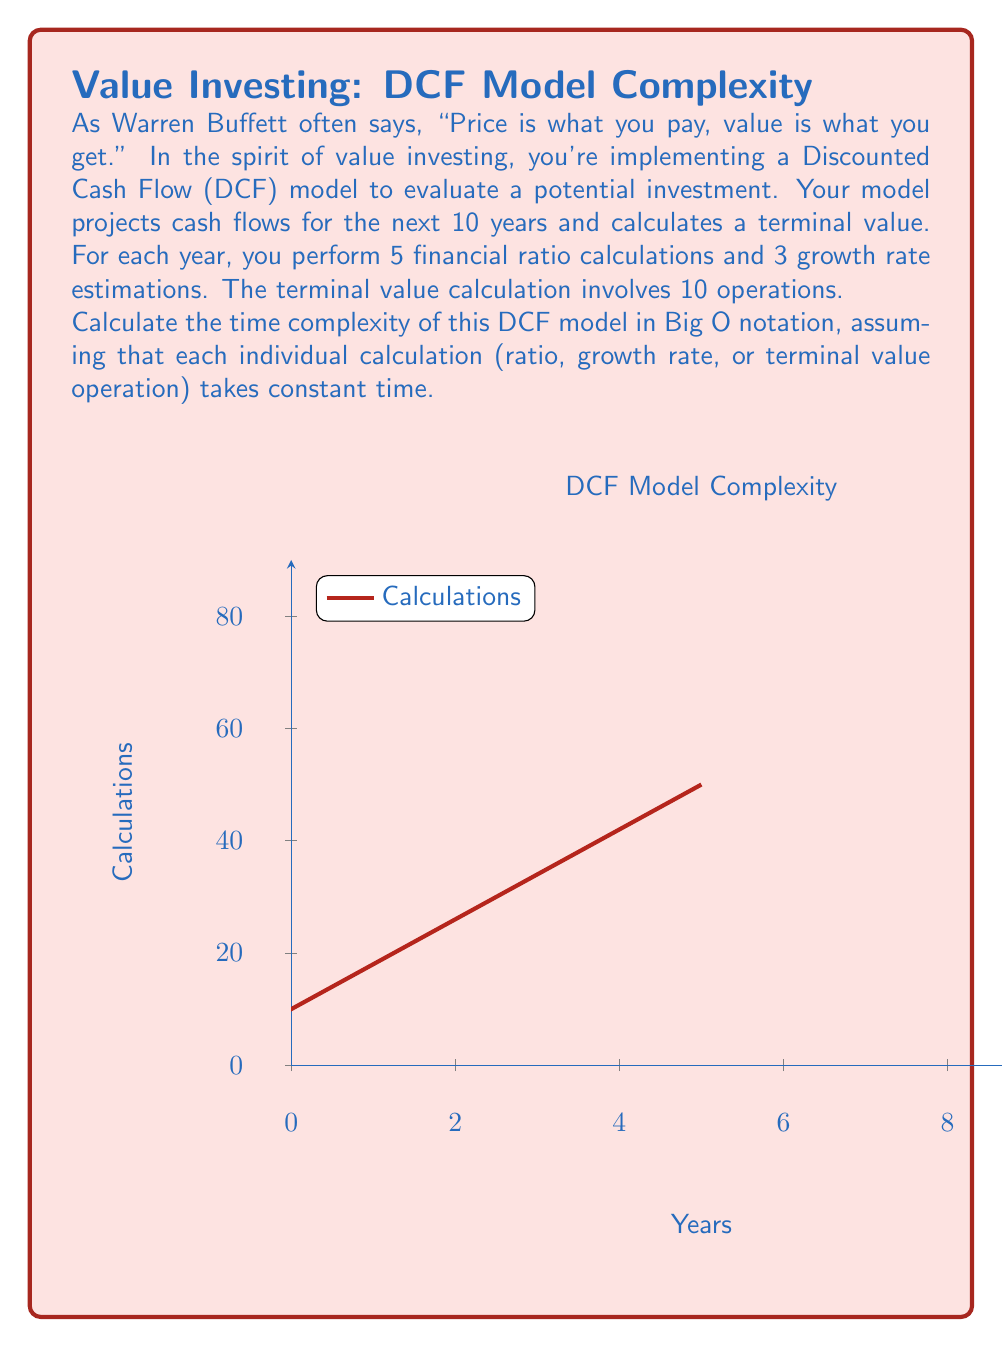Show me your answer to this math problem. Let's break down the problem and analyze the complexity step by step:

1) For each year in the 10-year projection:
   - 5 financial ratio calculations
   - 3 growth rate estimations
   Total operations per year: $5 + 3 = 8$

2) Number of years: 10

3) Total operations for cash flow projections:
   $10 \times 8 = 80$

4) Terminal value calculation: 10 operations

5) Total operations in the DCF model:
   $80 + 10 = 90$

The number of operations is constant and doesn't depend on any variable input size. In algorithm analysis, when the number of operations is fixed regardless of input size, we consider it as constant time.

Therefore, the time complexity of this DCF model is $O(1)$, or constant time.

However, it's worth noting that if the number of years were variable (let's call it $n$), the time complexity would be $O(n)$, as the number of operations would grow linearly with the number of years projected.
Answer: $O(1)$ 